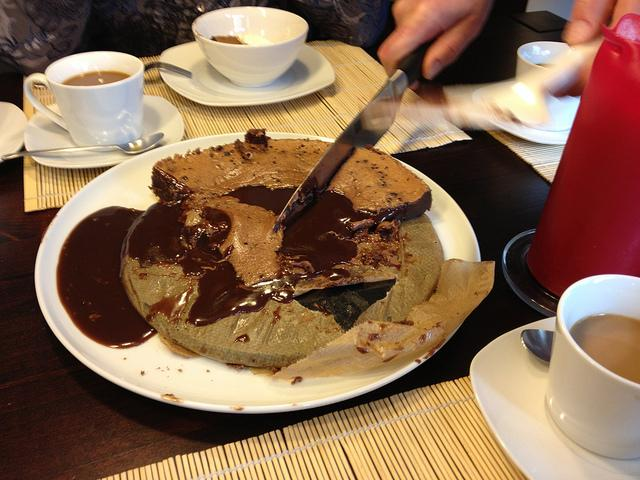What is being cut? Please explain your reasoning. gooey cake. The chocolate is really runny and sticky with a pastry. 